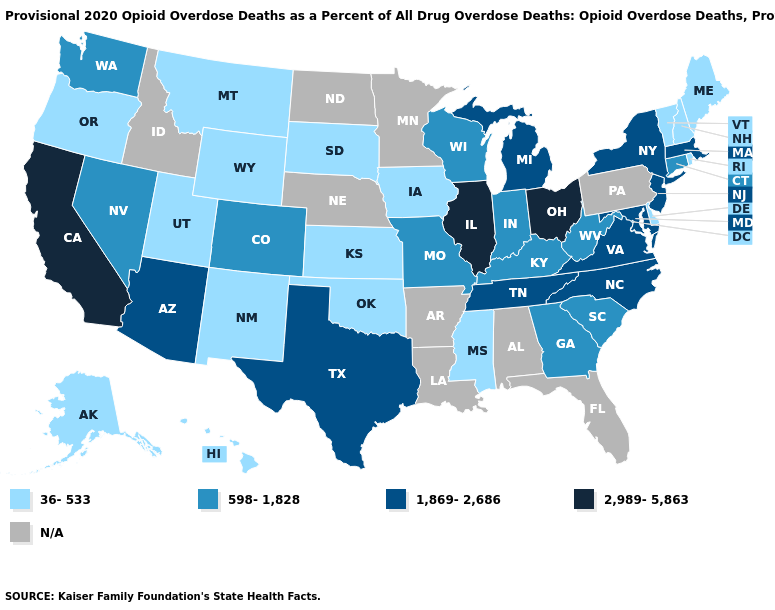What is the highest value in the USA?
Answer briefly. 2,989-5,863. Which states hav the highest value in the Northeast?
Concise answer only. Massachusetts, New Jersey, New York. What is the value of West Virginia?
Quick response, please. 598-1,828. Name the states that have a value in the range 36-533?
Quick response, please. Alaska, Delaware, Hawaii, Iowa, Kansas, Maine, Mississippi, Montana, New Hampshire, New Mexico, Oklahoma, Oregon, Rhode Island, South Dakota, Utah, Vermont, Wyoming. Does the map have missing data?
Be succinct. Yes. What is the value of Utah?
Give a very brief answer. 36-533. What is the value of Louisiana?
Concise answer only. N/A. Among the states that border Iowa , which have the lowest value?
Concise answer only. South Dakota. What is the highest value in states that border Idaho?
Quick response, please. 598-1,828. Does New York have the highest value in the Northeast?
Keep it brief. Yes. Name the states that have a value in the range N/A?
Be succinct. Alabama, Arkansas, Florida, Idaho, Louisiana, Minnesota, Nebraska, North Dakota, Pennsylvania. Does Alaska have the lowest value in the USA?
Keep it brief. Yes. What is the value of Colorado?
Give a very brief answer. 598-1,828. What is the value of Tennessee?
Quick response, please. 1,869-2,686. What is the lowest value in the Northeast?
Give a very brief answer. 36-533. 